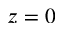Convert formula to latex. <formula><loc_0><loc_0><loc_500><loc_500>z = 0</formula> 